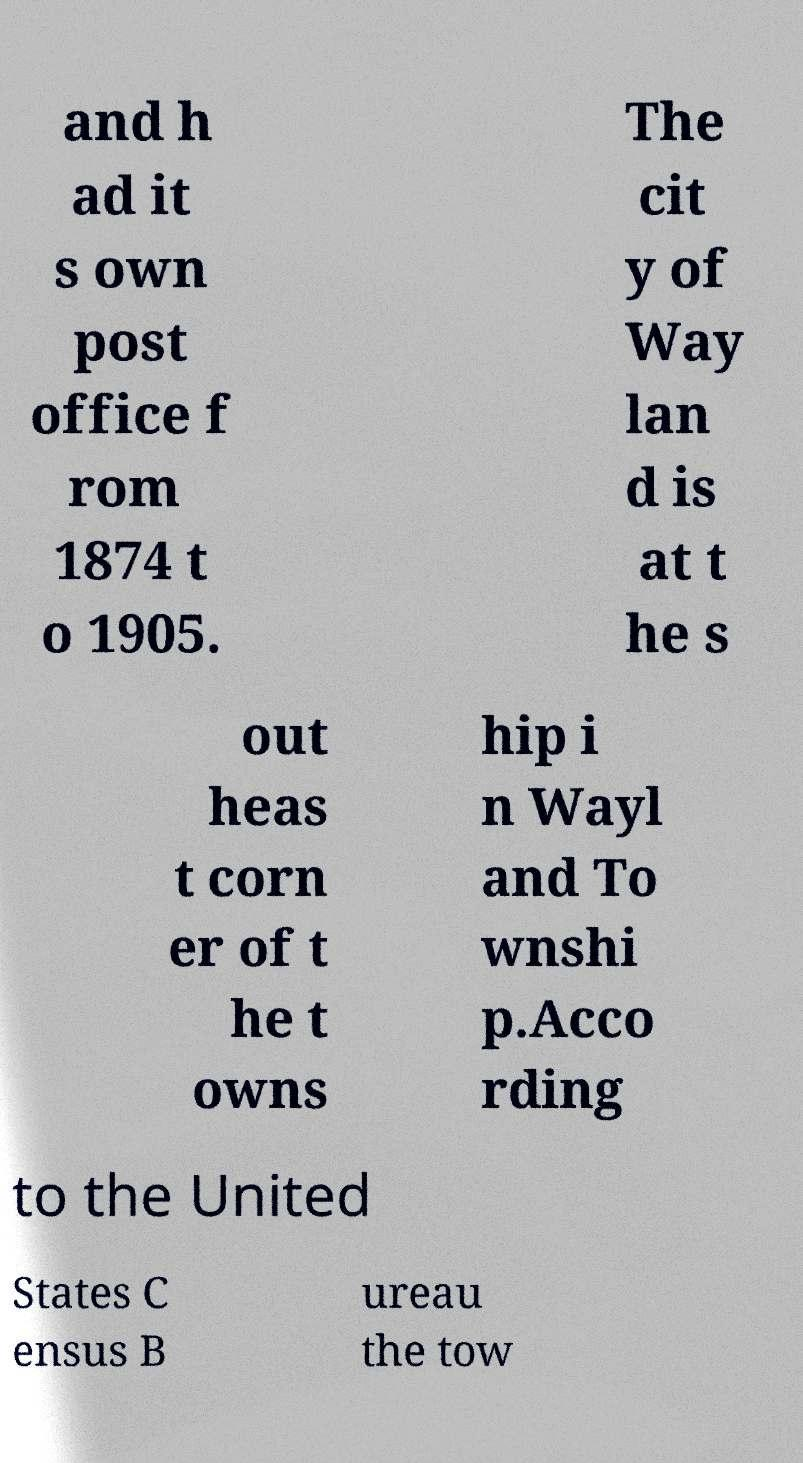Please identify and transcribe the text found in this image. and h ad it s own post office f rom 1874 t o 1905. The cit y of Way lan d is at t he s out heas t corn er of t he t owns hip i n Wayl and To wnshi p.Acco rding to the United States C ensus B ureau the tow 